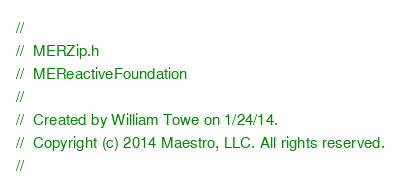Convert code to text. <code><loc_0><loc_0><loc_500><loc_500><_C_>//
//  MERZip.h
//  MEReactiveFoundation
//
//  Created by William Towe on 1/24/14.
//  Copyright (c) 2014 Maestro, LLC. All rights reserved.
//</code> 